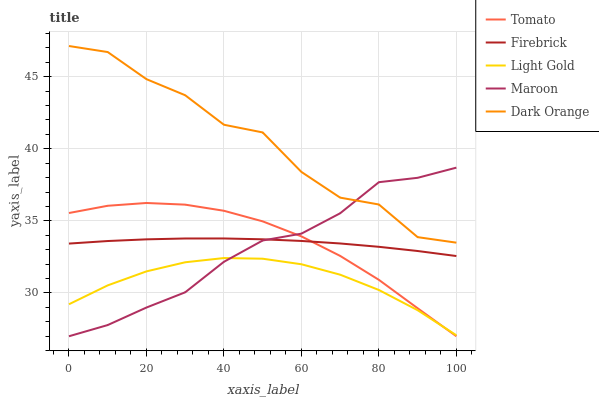Does Light Gold have the minimum area under the curve?
Answer yes or no. Yes. Does Dark Orange have the maximum area under the curve?
Answer yes or no. Yes. Does Firebrick have the minimum area under the curve?
Answer yes or no. No. Does Firebrick have the maximum area under the curve?
Answer yes or no. No. Is Firebrick the smoothest?
Answer yes or no. Yes. Is Dark Orange the roughest?
Answer yes or no. Yes. Is Dark Orange the smoothest?
Answer yes or no. No. Is Firebrick the roughest?
Answer yes or no. No. Does Tomato have the lowest value?
Answer yes or no. Yes. Does Firebrick have the lowest value?
Answer yes or no. No. Does Dark Orange have the highest value?
Answer yes or no. Yes. Does Firebrick have the highest value?
Answer yes or no. No. Is Light Gold less than Firebrick?
Answer yes or no. Yes. Is Dark Orange greater than Light Gold?
Answer yes or no. Yes. Does Maroon intersect Tomato?
Answer yes or no. Yes. Is Maroon less than Tomato?
Answer yes or no. No. Is Maroon greater than Tomato?
Answer yes or no. No. Does Light Gold intersect Firebrick?
Answer yes or no. No. 